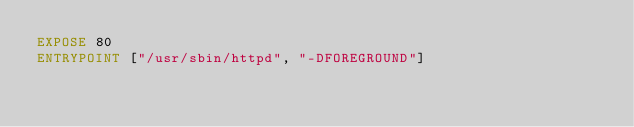Convert code to text. <code><loc_0><loc_0><loc_500><loc_500><_Dockerfile_>EXPOSE 80
ENTRYPOINT ["/usr/sbin/httpd", "-DFOREGROUND"]

</code> 